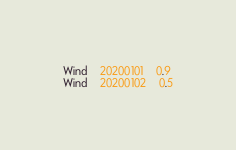Convert code to text. <code><loc_0><loc_0><loc_500><loc_500><_SQL_>Wind	20200101	0.9
Wind	20200102	0.5
</code> 